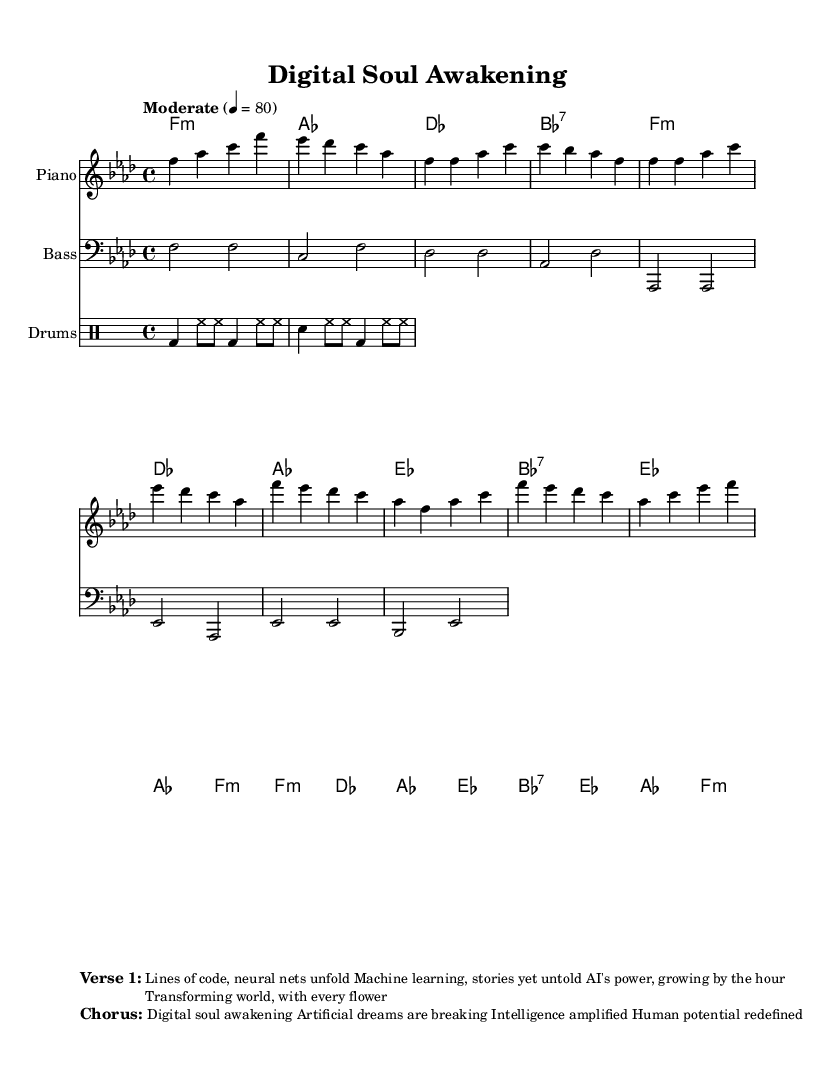What is the key signature of this music? The key signature is identified by the presence of B♭ and E♭ in the staff, which defines the key of F minor.
Answer: F minor What is the time signature of this music? The time signature is found at the beginning of the score, shown as 4/4, indicating four beats in each measure.
Answer: 4/4 What is the tempo marking of this music? The tempo marking is indicated in the score as "Moderate" with a metronomic marking of 80 beats per minute, giving a sense of the piece's pace.
Answer: Moderate 4 = 80 How many measures are in the chorus section? The chorus section consists of a total of 8 measures, as indicated by the notation in the score.
Answer: 8 measures What is the main theme of the lyrics in the chorus? The lyrical content of the chorus emphasizes concepts related to artificial intelligence and human potential, discussing digital awakening and intelligence amplification.
Answer: Digital soul awakening Which instruments are included in this composition? The score contains notations for Piano, Bass, and Drums, listed explicitly in the staff sections of the sheet music.
Answer: Piano, Bass, Drums What emotional quality is conveyed by the overall structure of the piece? The combination of soulful melodies, harmonies, and lyrics suggests a deep emotional transformation, reflecting a journey of awakening through technology.
Answer: Soulful transformation 